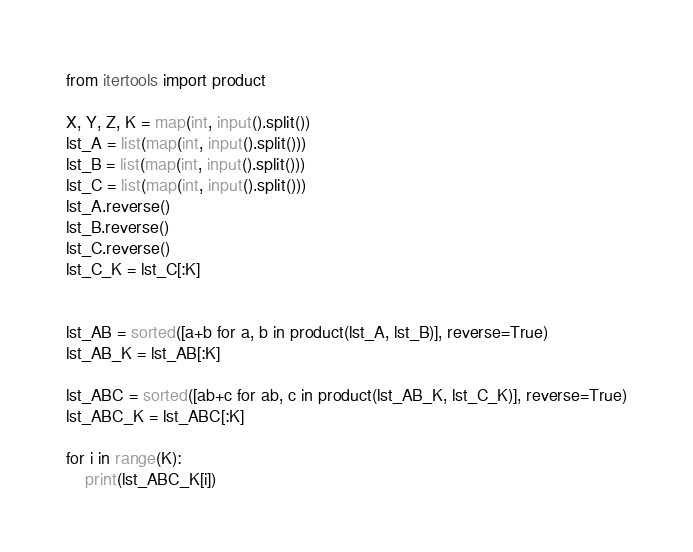<code> <loc_0><loc_0><loc_500><loc_500><_Python_>from itertools import product

X, Y, Z, K = map(int, input().split())
lst_A = list(map(int, input().split()))
lst_B = list(map(int, input().split()))
lst_C = list(map(int, input().split()))
lst_A.reverse()
lst_B.reverse()
lst_C.reverse()
lst_C_K = lst_C[:K]


lst_AB = sorted([a+b for a, b in product(lst_A, lst_B)], reverse=True)
lst_AB_K = lst_AB[:K]

lst_ABC = sorted([ab+c for ab, c in product(lst_AB_K, lst_C_K)], reverse=True)
lst_ABC_K = lst_ABC[:K]

for i in range(K):
    print(lst_ABC_K[i])
</code> 